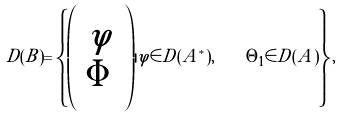Convert formula to latex. <formula><loc_0><loc_0><loc_500><loc_500>D ( B ) = \left \{ \left ( \begin{array} { c } \varphi \\ \Phi \end{array} \right ) | \varphi \in D ( A ^ { * } ) , \quad \Theta _ { 1 } \in D ( \tilde { A } ) \right \} ,</formula> 